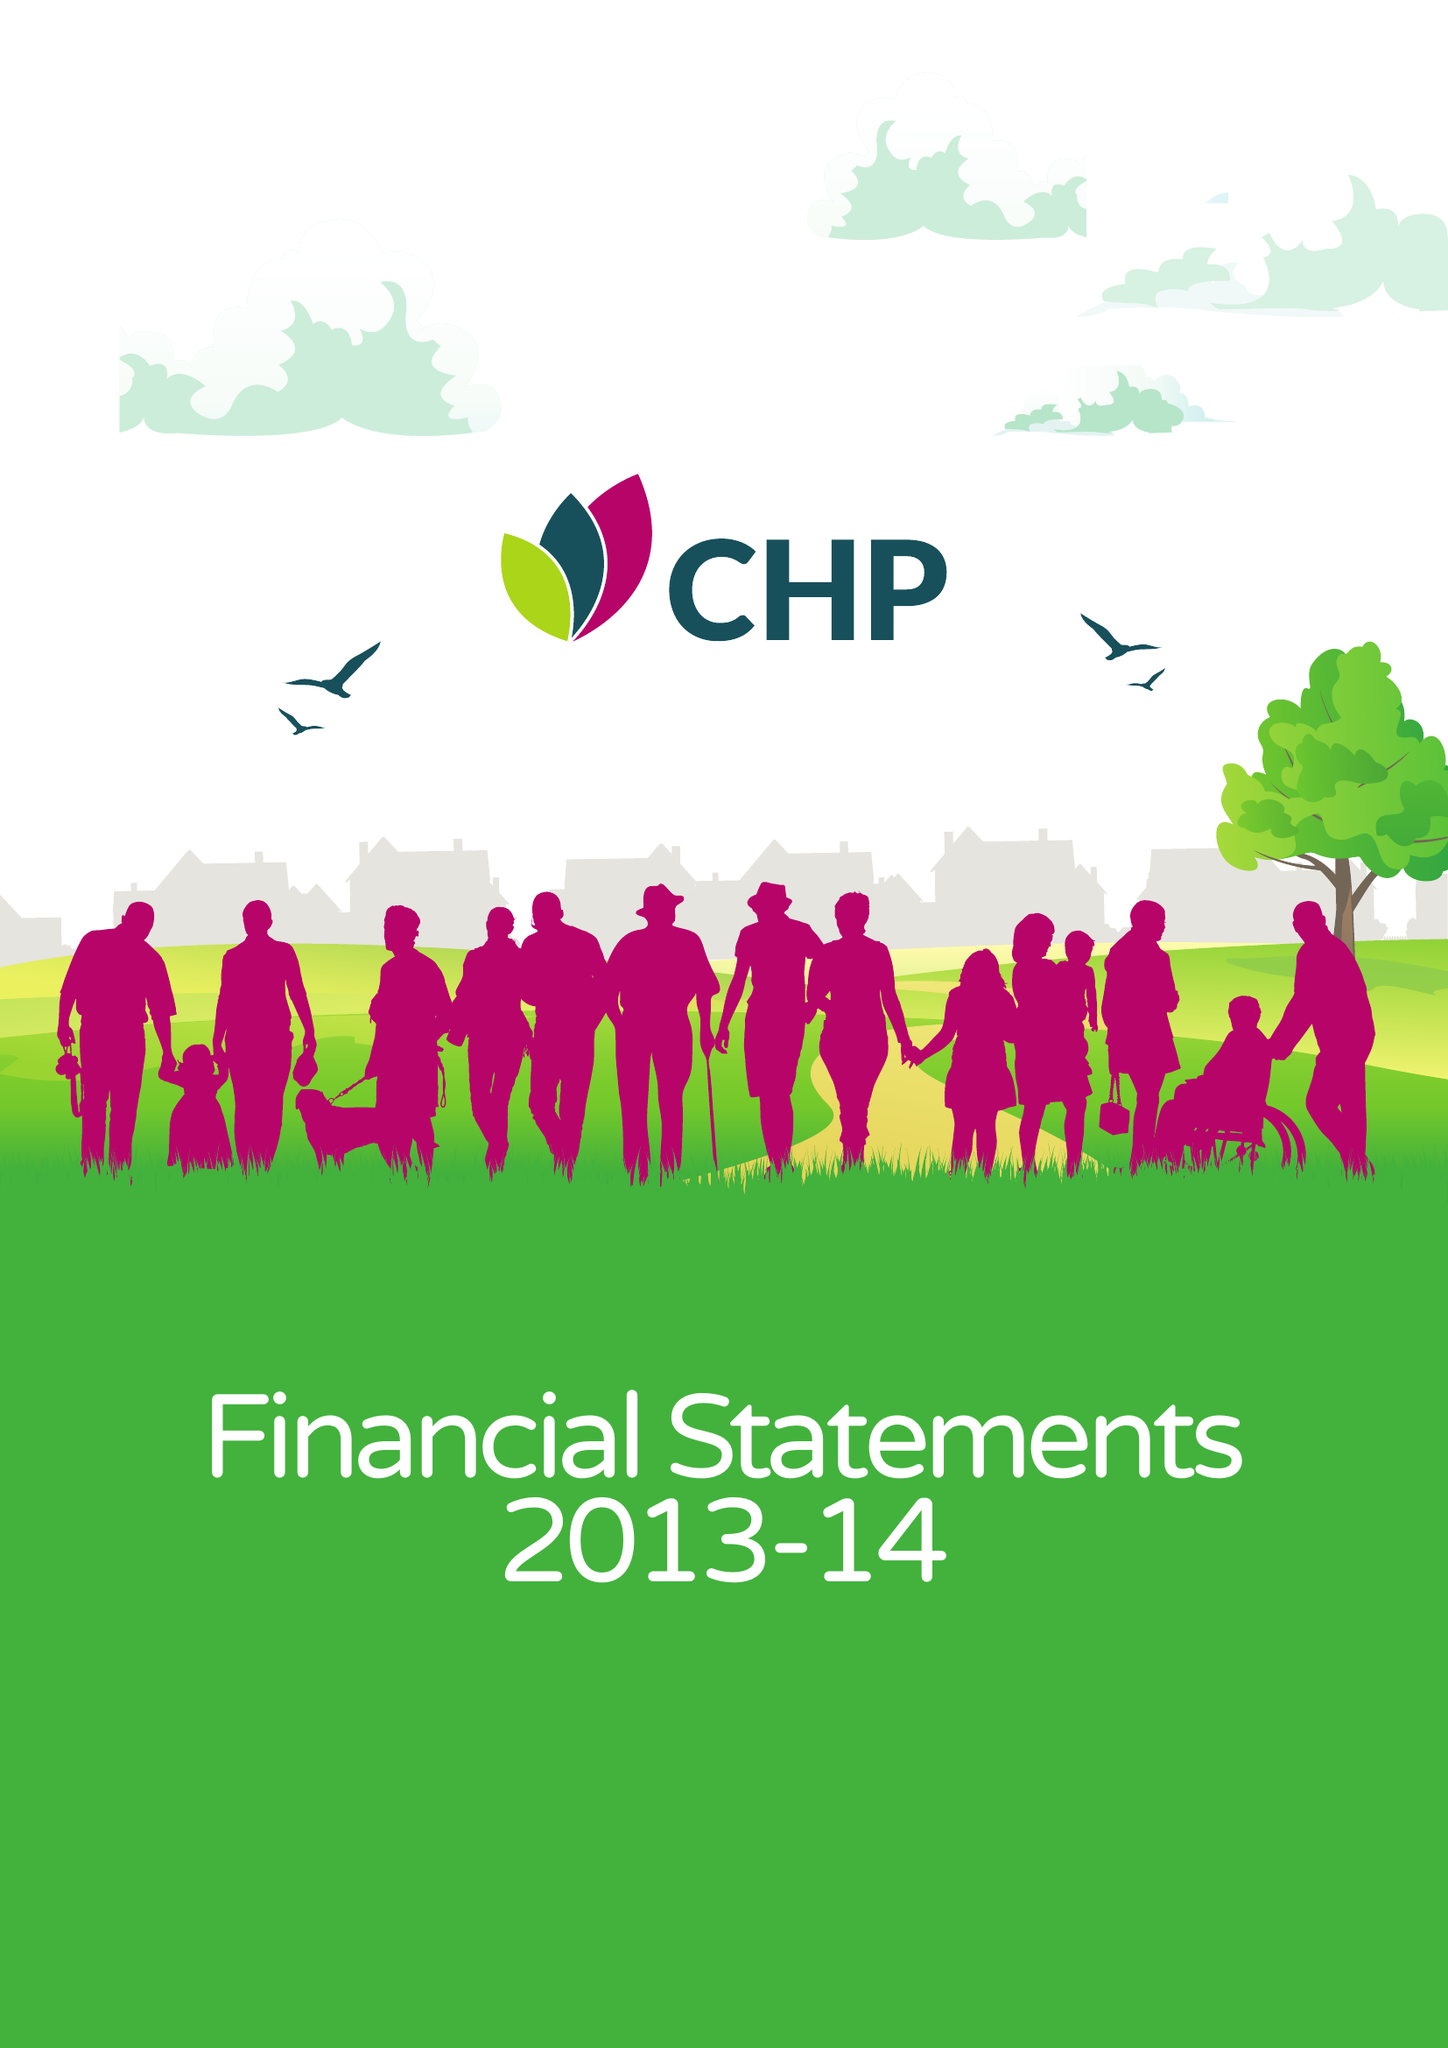What is the value for the address__post_town?
Answer the question using a single word or phrase. CHELMSFORD 